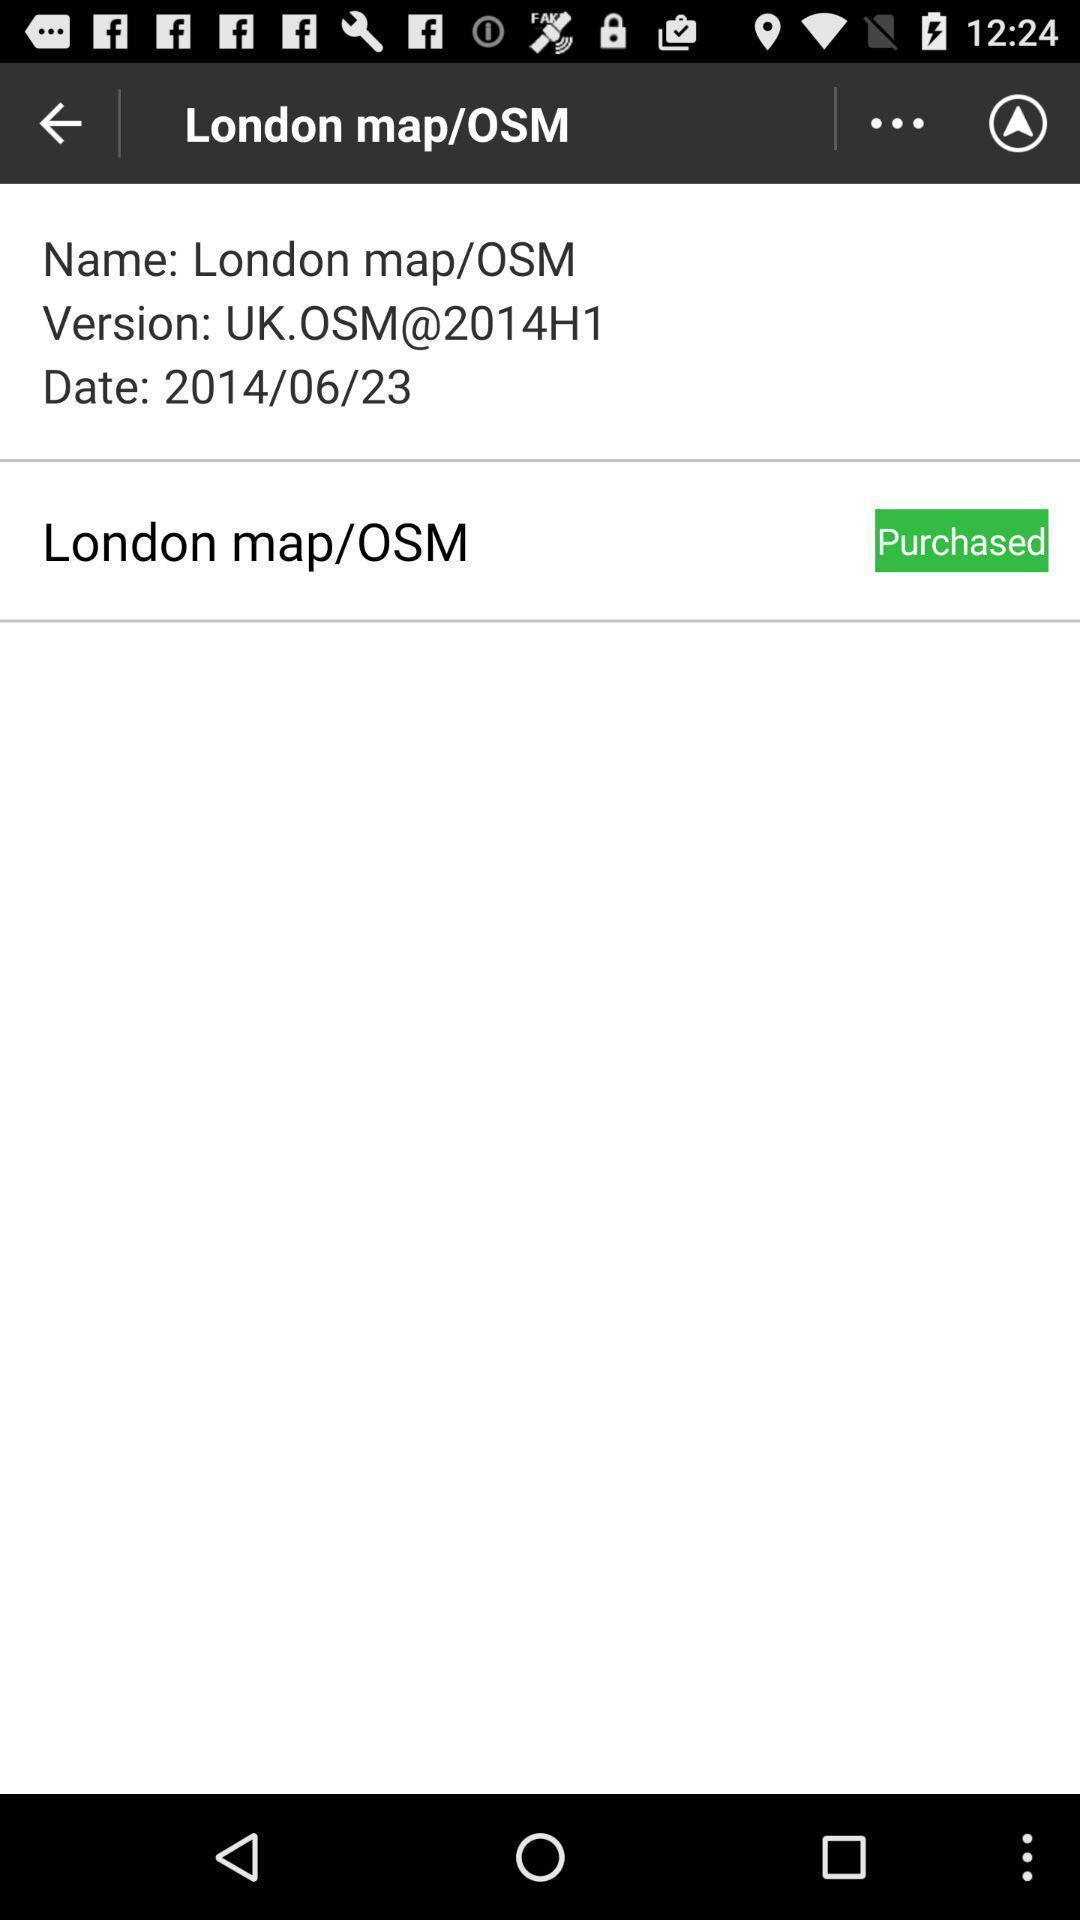What is the overall content of this screenshot? Screen displaying the location information in navigation application. 